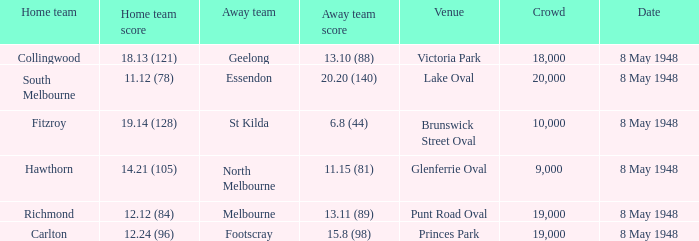How many spectators were at the game when the away team scored 15.8 (98)? 19000.0. 